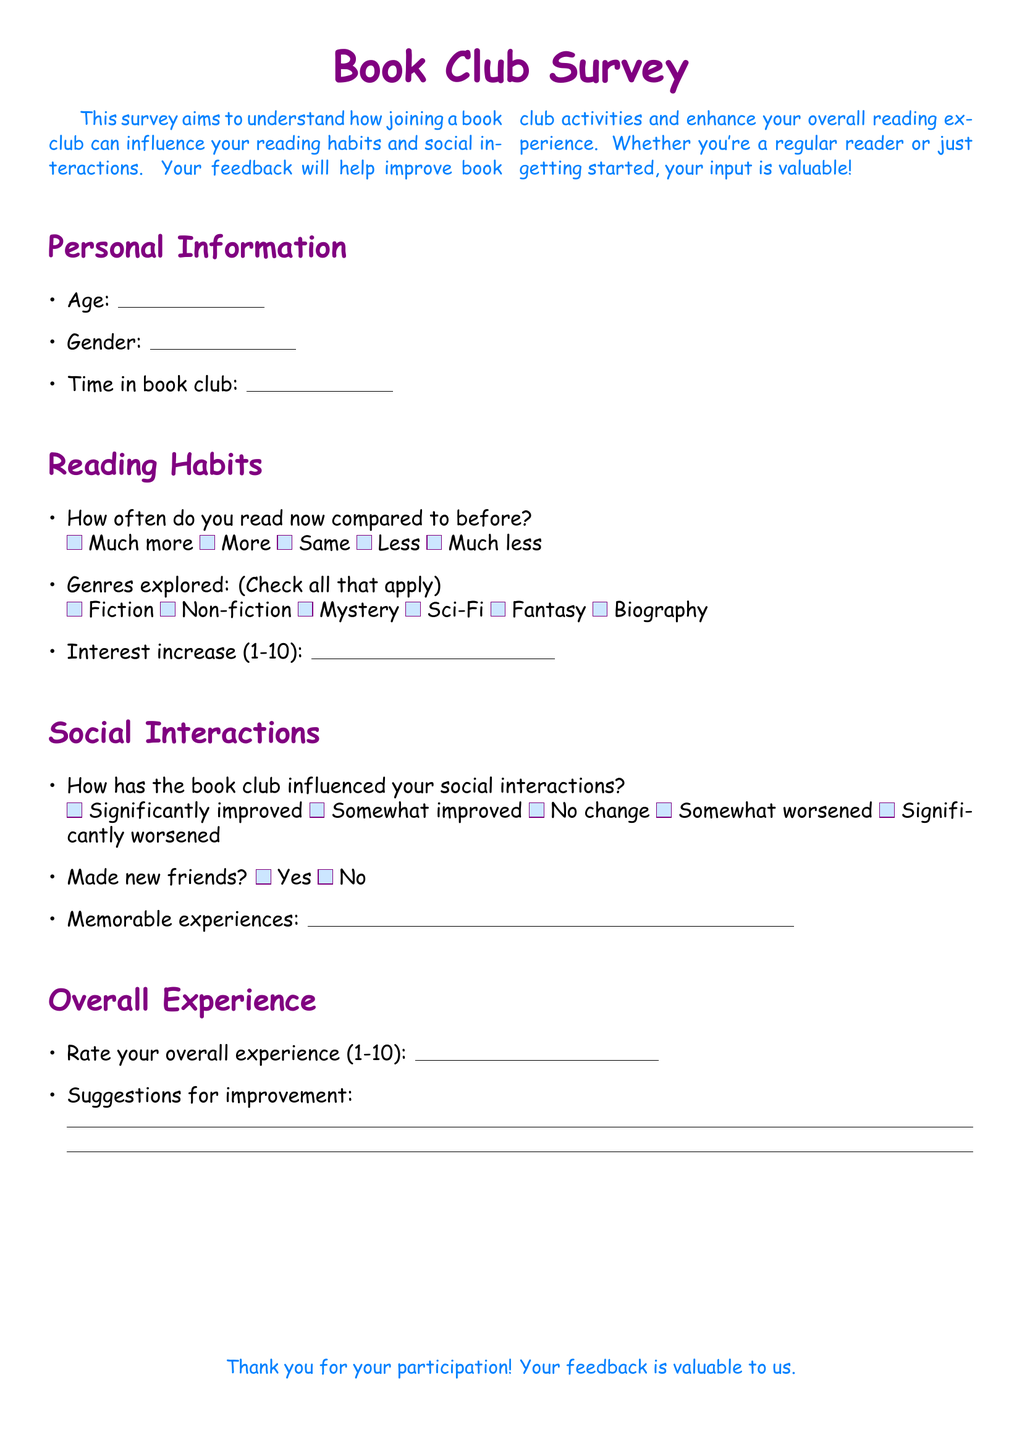What is the title of the survey? The title of the survey is mentioned at the center of the document and is "Book Club Survey."
Answer: Book Club Survey What color is used for the main text font? The main text font color is specified in the document and is referred to as teenblue.
Answer: teenblue How many sections are there in the survey? The survey contains four sections: Personal Information, Reading Habits, Social Interactions, and Overall Experience.
Answer: Four What is the maximum rating for the overall experience? The document specifies that participants are to rate their overall experience on a scale from 1 to 10.
Answer: 10 What types of genres can be checked off in the survey? The survey asks participants to check all the genres they have explored, which include Fiction, Non-fiction, Mystery, Sci-Fi, Fantasy, and Biography.
Answer: Fiction, Non-fiction, Mystery, Sci-Fi, Fantasy, Biography How has the book club influenced social interactions according to the options? The survey provides five options for how the book club has influenced social interactions, from significantly improved to significantly worsened.
Answer: Significantly improved Is there a space for suggestions for improvement in the document? The document includes a section where participants can write suggestions for improvement.
Answer: Yes What is the purpose of the survey? The purpose is indicated in the introduction and aims to understand the impact of book club participation on reading habits and social interactions.
Answer: Understand impact How long should the responses be for the memorable experiences question? The survey provides a ruler indicating the space for responses to the memorable experiences question, signaling a prompt for concise reflections.
Answer: Ten centimeters 